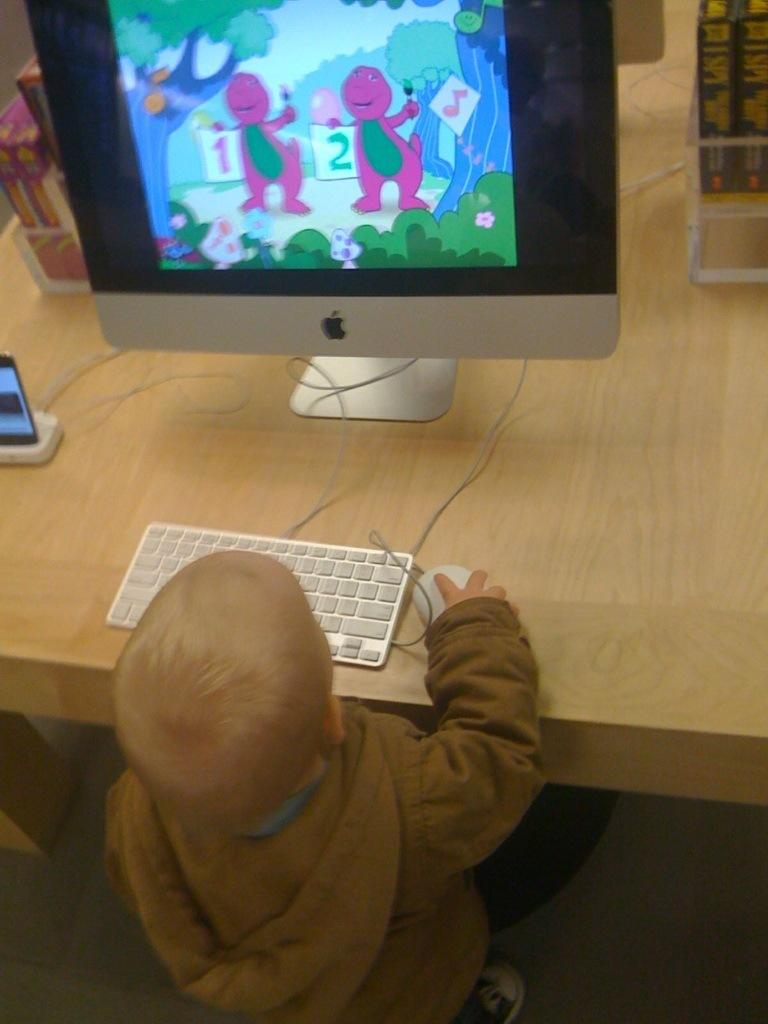What is the main subject of the image? The main subject of the image is a small boy. What is the boy doing in the image? The boy is standing and playing a game on a computer. What can be seen on the table in the image? There is a monitor, a keyboard, a mouse, a cell phone charger, a cell phone, and some books on the table. What is the purpose of the cell phone charger on the table? The cell phone charger is used to charge the cell phone. What might the boy be using to interact with the computer? The boy might be using the mouse to interact with the computer. What type of shade is covering the boy while he plays the game? There is no shade covering the boy in the image; he is standing in front of the table. --- Facts: 1. There is a group of people in the image. 2. The people are wearing hats. 3. The people are holding umbrellas. 4. The ground is wet. 5. There are puddles on the ground. Absurd Topics: snow, sandcastle, parrot Conversation: How many people are in the image? There is a group of people in the image. What are the people wearing on their heads? The people are wearing hats. What are the people holding in their hands? The people are holding umbrellas. What is the condition of the ground in the image? The ground is wet in the image. What can be seen on the wet ground? There are puddles on the ground. Reasoning: Let's think step by step in order to produce the conversation. We start by identifying the main subject of the image, which is the group of people. Then, we describe what the people are wearing and holding, which are hats and umbrellas, respectively. Next, we focus on the ground and its condition, mentioning that it is wet and has puddles. Absurd Question/Answer: What type of snow can be seen on the sandcastle in the image? There is no snow or sandcastle present in the image. --- Facts: 1. There is a car in the image. 2. The car is parked on the street. 3. The car has a flat tire. 4. There is a person standing next to the car. 5. The person is holding a cell phone. Absurd Topics: bird, ocean, bicycle Conversation: What is the main subject of the image? The main subject of the image is a car. Where is the car located in the image? The car is parked on 